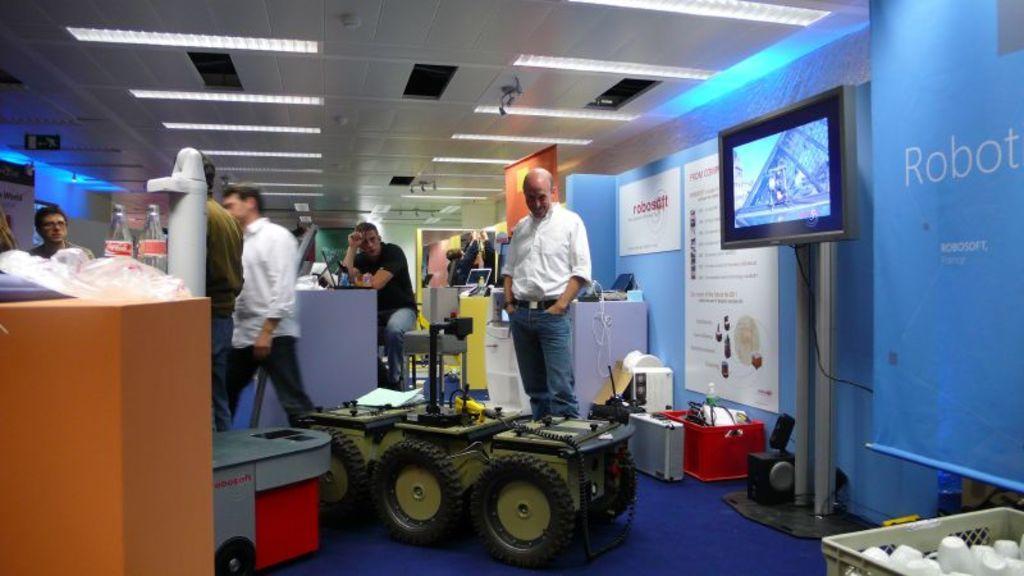Could you give a brief overview of what you see in this image? In this image we can see the vehicles. We can also see a man sitting. We can see the people standing on the floor. We can also see the posts attached to the wall. We can see the television screen, laptop, sound box and also some other objects. We can also see the banners, board and also the wire. On the left we can see the bottles and a cover on the counter. On the right we can see the cups in a basket. We can also see the ceiling with the lights. 